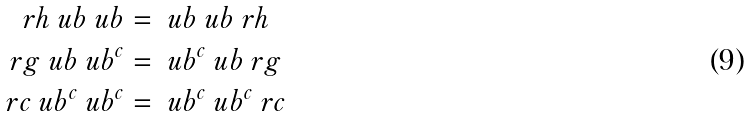<formula> <loc_0><loc_0><loc_500><loc_500>\ r h \ u b \ u b & = \ u b \ u b \ r h \\ \ r g \ u b \ u b ^ { c } & = \ u b ^ { c } \ u b \ r g \\ \ r c \ u b ^ { c } \ u b ^ { c } & = \ u b ^ { c } \ u b ^ { c } \ r c</formula> 